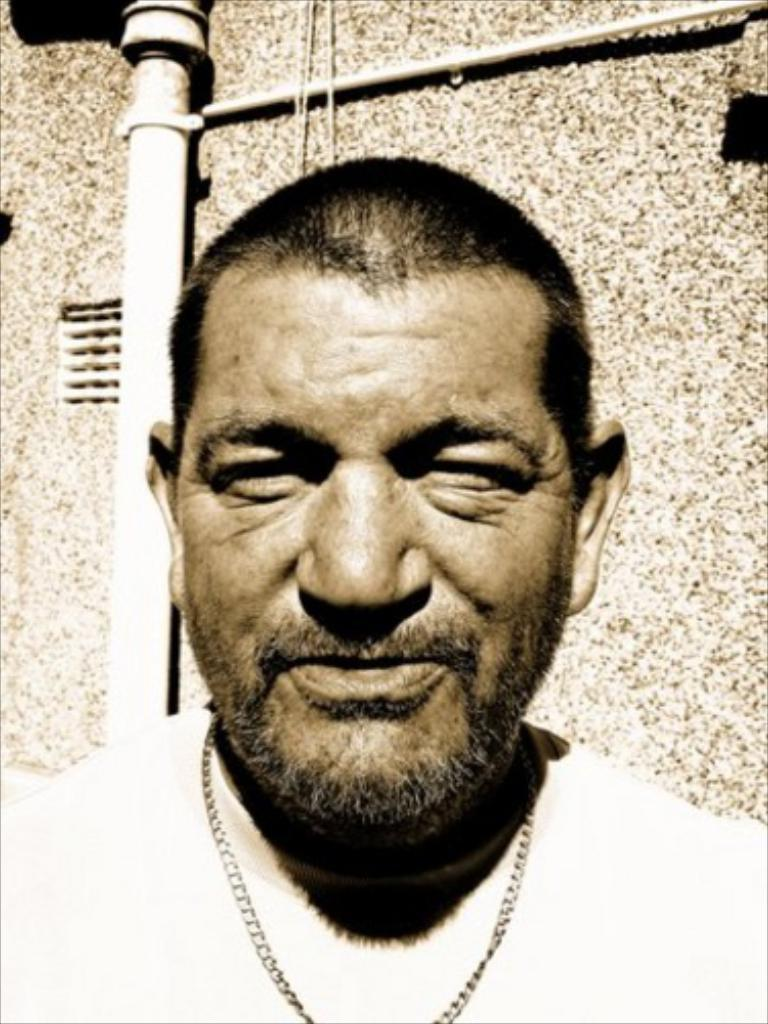Who is present in the image? There is a man in the image. What is the man doing in the image? The man is standing and smiling. What can be seen in the background of the image? There is a pipe in the background of the image. Where is the pipe attached? The pipe is attached to a building wall. What type of nest can be seen in the image? There is no nest present in the image. 